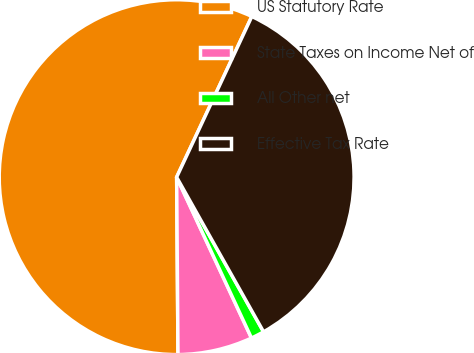Convert chart. <chart><loc_0><loc_0><loc_500><loc_500><pie_chart><fcel>US Statutory Rate<fcel>State Taxes on Income Net of<fcel>All Other net<fcel>Effective Tax Rate<nl><fcel>57.09%<fcel>6.81%<fcel>1.22%<fcel>34.89%<nl></chart> 